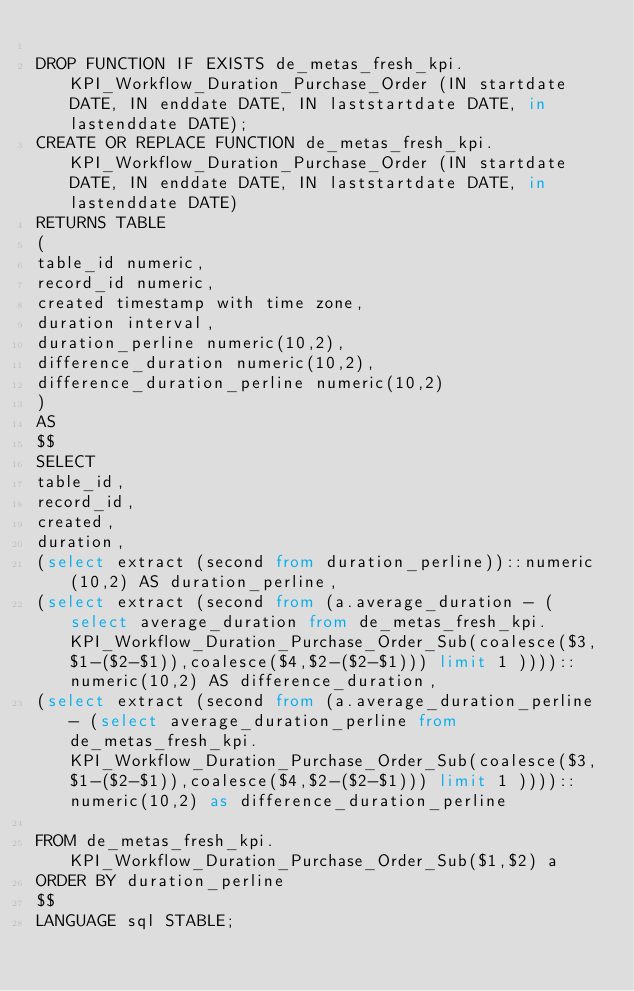<code> <loc_0><loc_0><loc_500><loc_500><_SQL_>
DROP FUNCTION IF EXISTS de_metas_fresh_kpi.KPI_Workflow_Duration_Purchase_Order (IN startdate DATE, IN enddate DATE, IN laststartdate DATE, in lastenddate DATE);
CREATE OR REPLACE FUNCTION de_metas_fresh_kpi.KPI_Workflow_Duration_Purchase_Order (IN startdate DATE, IN enddate DATE, IN laststartdate DATE, in lastenddate DATE)
RETURNS TABLE 
(
table_id numeric,
record_id numeric,
created timestamp with time zone,
duration interval,
duration_perline numeric(10,2),
difference_duration numeric(10,2),
difference_duration_perline numeric(10,2)
)
AS
$$
SELECT 
table_id,
record_id,
created,
duration,
(select extract (second from duration_perline))::numeric(10,2) AS duration_perline,
(select extract (second from (a.average_duration - (select average_duration from de_metas_fresh_kpi.KPI_Workflow_Duration_Purchase_Order_Sub(coalesce($3,$1-($2-$1)),coalesce($4,$2-($2-$1))) limit 1 ))))::numeric(10,2) AS difference_duration,
(select extract (second from (a.average_duration_perline - (select average_duration_perline from de_metas_fresh_kpi.KPI_Workflow_Duration_Purchase_Order_Sub(coalesce($3,$1-($2-$1)),coalesce($4,$2-($2-$1))) limit 1 ))))::numeric(10,2) as difference_duration_perline

FROM de_metas_fresh_kpi.KPI_Workflow_Duration_Purchase_Order_Sub($1,$2) a
ORDER BY duration_perline
$$
LANGUAGE sql STABLE;
</code> 